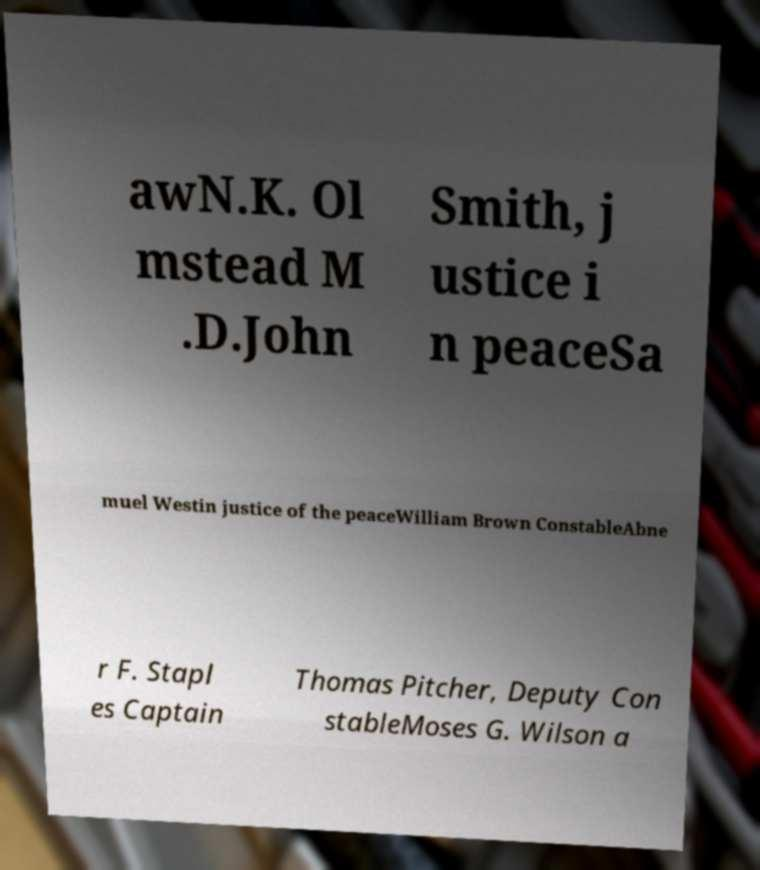Can you read and provide the text displayed in the image?This photo seems to have some interesting text. Can you extract and type it out for me? awN.K. Ol mstead M .D.John Smith, j ustice i n peaceSa muel Westin justice of the peaceWilliam Brown ConstableAbne r F. Stapl es Captain Thomas Pitcher, Deputy Con stableMoses G. Wilson a 